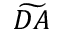Convert formula to latex. <formula><loc_0><loc_0><loc_500><loc_500>\widetilde { D A }</formula> 